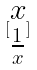<formula> <loc_0><loc_0><loc_500><loc_500>[ \begin{matrix} x \\ \frac { 1 } { x } \end{matrix} ]</formula> 